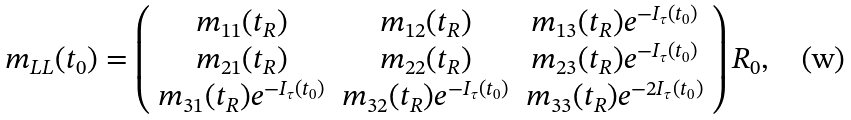<formula> <loc_0><loc_0><loc_500><loc_500>m _ { L L } ( t _ { 0 } ) = \left ( \begin{array} { c c c } m _ { 1 1 } ( t _ { R } ) & m _ { 1 2 } ( t _ { R } ) & m _ { 1 3 } ( t _ { R } ) e ^ { - I _ { \tau } ( t _ { 0 } ) } \\ m _ { 2 1 } ( t _ { R } ) & m _ { 2 2 } ( t _ { R } ) & m _ { 2 3 } ( t _ { R } ) e ^ { - I _ { \tau } ( t _ { 0 } ) } \\ m _ { 3 1 } ( t _ { R } ) e ^ { - I _ { \tau } ( t _ { 0 } ) } & m _ { 3 2 } ( t _ { R } ) e ^ { - I _ { \tau } ( t _ { 0 } ) } & m _ { 3 3 } ( t _ { R } ) e ^ { - 2 I _ { \tau } ( t _ { 0 } ) } \\ \end{array} \right ) R _ { 0 } ,</formula> 